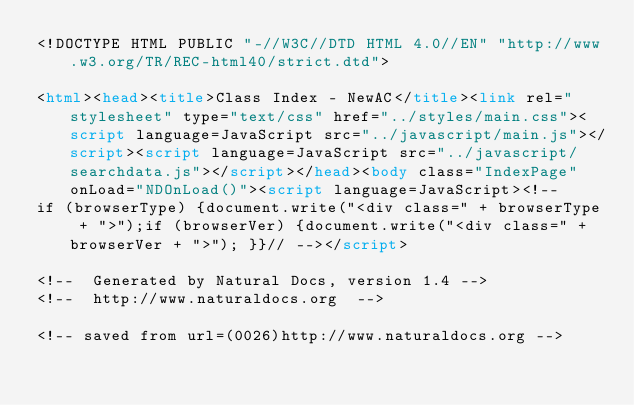<code> <loc_0><loc_0><loc_500><loc_500><_HTML_><!DOCTYPE HTML PUBLIC "-//W3C//DTD HTML 4.0//EN" "http://www.w3.org/TR/REC-html40/strict.dtd">

<html><head><title>Class Index - NewAC</title><link rel="stylesheet" type="text/css" href="../styles/main.css"><script language=JavaScript src="../javascript/main.js"></script><script language=JavaScript src="../javascript/searchdata.js"></script></head><body class="IndexPage" onLoad="NDOnLoad()"><script language=JavaScript><!--
if (browserType) {document.write("<div class=" + browserType + ">");if (browserVer) {document.write("<div class=" + browserVer + ">"); }}// --></script>

<!--  Generated by Natural Docs, version 1.4 -->
<!--  http://www.naturaldocs.org  -->

<!-- saved from url=(0026)http://www.naturaldocs.org -->



</code> 